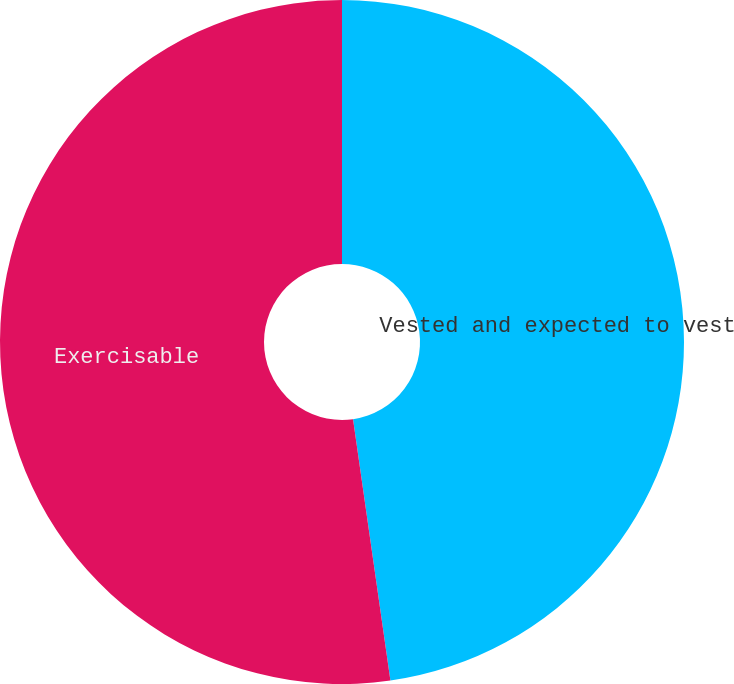Convert chart. <chart><loc_0><loc_0><loc_500><loc_500><pie_chart><fcel>Vested and expected to vest<fcel>Exercisable<nl><fcel>47.74%<fcel>52.26%<nl></chart> 